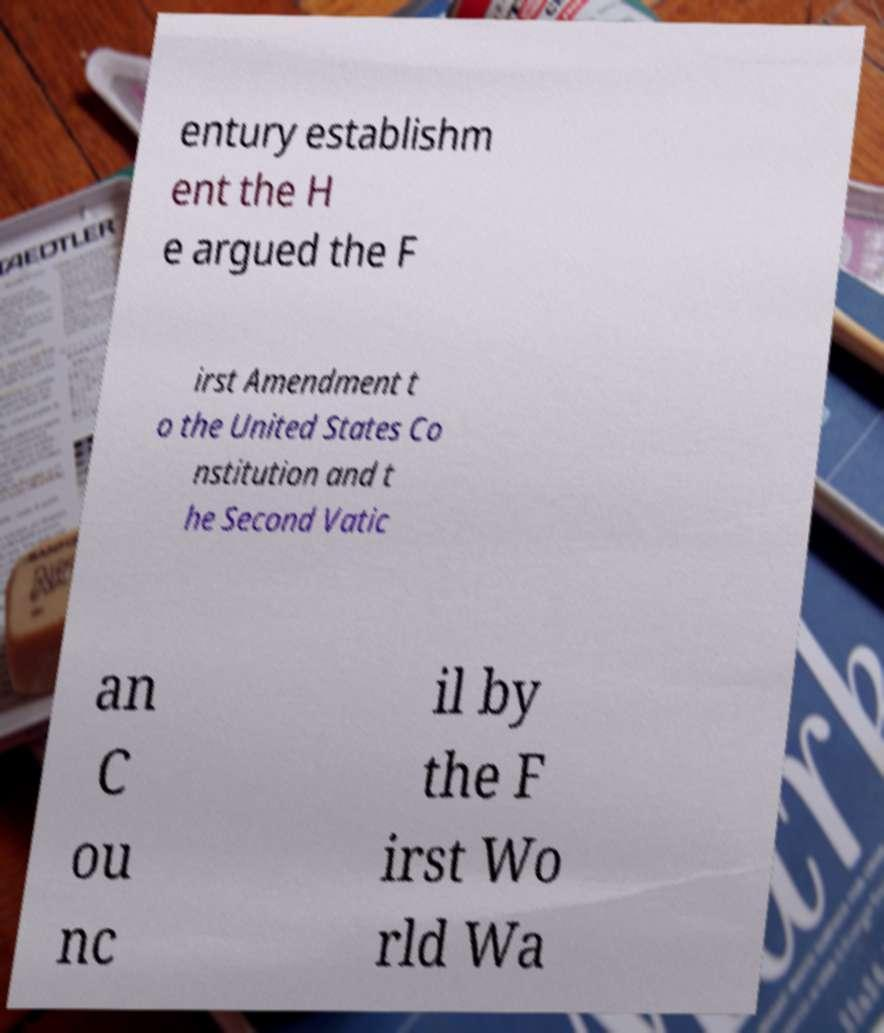Please read and relay the text visible in this image. What does it say? entury establishm ent the H e argued the F irst Amendment t o the United States Co nstitution and t he Second Vatic an C ou nc il by the F irst Wo rld Wa 